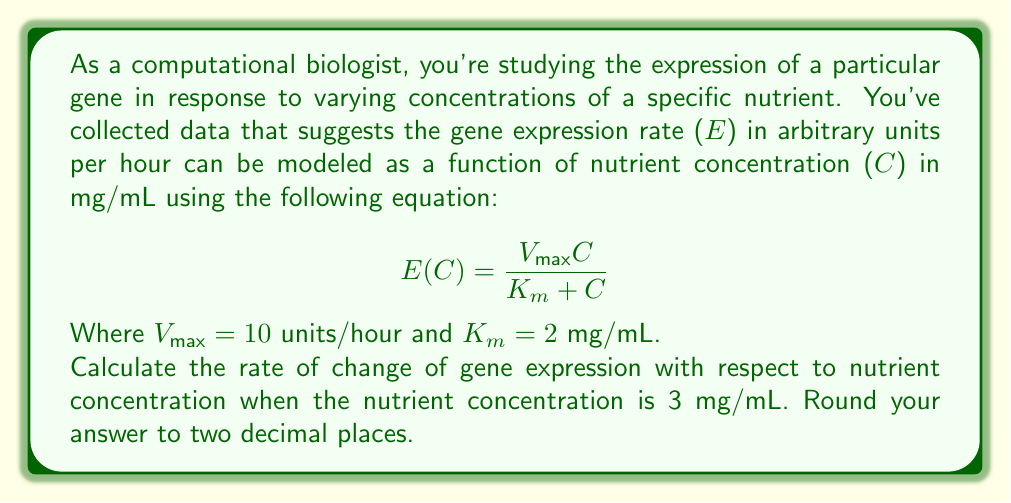Help me with this question. To solve this problem, we need to find the derivative of the gene expression function E(C) with respect to C and then evaluate it at C = 3 mg/mL.

1) First, let's find the derivative of E(C) with respect to C using the quotient rule:

   $$ \frac{d}{dC}E(C) = \frac{d}{dC}\left(\frac{V_{max}C}{K_m + C}\right) $$

   $$ = \frac{V_{max}(K_m + C) - V_{max}C \cdot 1}{(K_m + C)^2} $$

   $$ = \frac{V_{max}K_m}{(K_m + C)^2} $$

2) Now we have the general formula for the rate of change of gene expression with respect to nutrient concentration:

   $$ \frac{dE}{dC} = \frac{V_{max}K_m}{(K_m + C)^2} $$

3) We can substitute the given values $V_{max} = 10$ and $K_m = 2$:

   $$ \frac{dE}{dC} = \frac{10 \cdot 2}{(2 + C)^2} = \frac{20}{(2 + C)^2} $$

4) Now, we evaluate this at C = 3 mg/mL:

   $$ \left.\frac{dE}{dC}\right|_{C=3} = \frac{20}{(2 + 3)^2} = \frac{20}{25} = 0.8 $$

Thus, the rate of change of gene expression with respect to nutrient concentration at C = 3 mg/mL is 0.8 units/hour per mg/mL.
Answer: 0.80 units/hour per mg/mL 